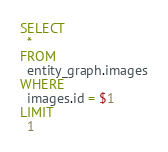<code> <loc_0><loc_0><loc_500><loc_500><_SQL_>SELECT
  *
FROM
  entity_graph.images
WHERE
  images.id = $1
LIMIT
  1
</code> 